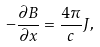<formula> <loc_0><loc_0><loc_500><loc_500>- \frac { \partial B } { \partial x } = \frac { 4 \pi } { c } J ,</formula> 